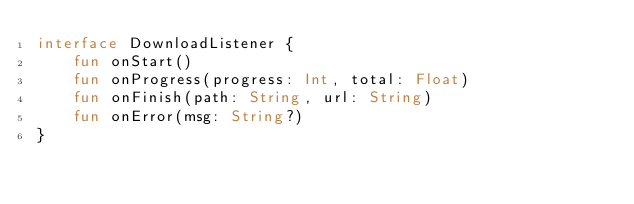Convert code to text. <code><loc_0><loc_0><loc_500><loc_500><_Kotlin_>interface DownloadListener {
    fun onStart()
    fun onProgress(progress: Int, total: Float)
    fun onFinish(path: String, url: String)
    fun onError(msg: String?)
}</code> 